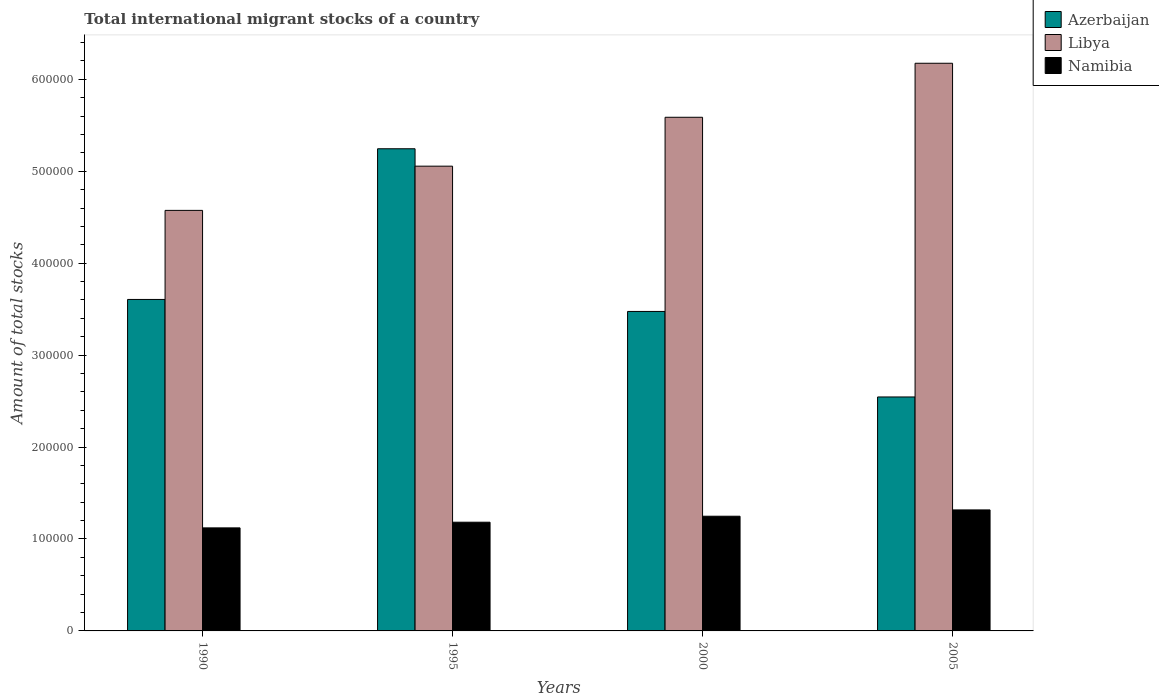How many different coloured bars are there?
Your answer should be compact. 3. Are the number of bars on each tick of the X-axis equal?
Ensure brevity in your answer.  Yes. How many bars are there on the 4th tick from the right?
Give a very brief answer. 3. In how many cases, is the number of bars for a given year not equal to the number of legend labels?
Ensure brevity in your answer.  0. What is the amount of total stocks in in Namibia in 2000?
Your answer should be compact. 1.25e+05. Across all years, what is the maximum amount of total stocks in in Namibia?
Offer a very short reply. 1.32e+05. Across all years, what is the minimum amount of total stocks in in Namibia?
Provide a short and direct response. 1.12e+05. What is the total amount of total stocks in in Namibia in the graph?
Make the answer very short. 4.87e+05. What is the difference between the amount of total stocks in in Azerbaijan in 1995 and that in 2005?
Your answer should be very brief. 2.70e+05. What is the difference between the amount of total stocks in in Azerbaijan in 2000 and the amount of total stocks in in Namibia in 1990?
Offer a very short reply. 2.35e+05. What is the average amount of total stocks in in Libya per year?
Give a very brief answer. 5.35e+05. In the year 1995, what is the difference between the amount of total stocks in in Azerbaijan and amount of total stocks in in Namibia?
Your answer should be compact. 4.06e+05. What is the ratio of the amount of total stocks in in Namibia in 1990 to that in 1995?
Provide a short and direct response. 0.95. Is the amount of total stocks in in Namibia in 2000 less than that in 2005?
Make the answer very short. Yes. Is the difference between the amount of total stocks in in Azerbaijan in 1990 and 1995 greater than the difference between the amount of total stocks in in Namibia in 1990 and 1995?
Give a very brief answer. No. What is the difference between the highest and the second highest amount of total stocks in in Namibia?
Your answer should be very brief. 6863. What is the difference between the highest and the lowest amount of total stocks in in Libya?
Give a very brief answer. 1.60e+05. In how many years, is the amount of total stocks in in Azerbaijan greater than the average amount of total stocks in in Azerbaijan taken over all years?
Ensure brevity in your answer.  1. Is the sum of the amount of total stocks in in Libya in 1990 and 1995 greater than the maximum amount of total stocks in in Namibia across all years?
Ensure brevity in your answer.  Yes. What does the 2nd bar from the left in 1995 represents?
Provide a short and direct response. Libya. What does the 1st bar from the right in 2000 represents?
Provide a succinct answer. Namibia. Is it the case that in every year, the sum of the amount of total stocks in in Libya and amount of total stocks in in Azerbaijan is greater than the amount of total stocks in in Namibia?
Keep it short and to the point. Yes. Are all the bars in the graph horizontal?
Provide a succinct answer. No. How many years are there in the graph?
Your answer should be very brief. 4. What is the difference between two consecutive major ticks on the Y-axis?
Your answer should be very brief. 1.00e+05. Are the values on the major ticks of Y-axis written in scientific E-notation?
Provide a succinct answer. No. Does the graph contain any zero values?
Provide a succinct answer. No. How many legend labels are there?
Your answer should be very brief. 3. What is the title of the graph?
Provide a succinct answer. Total international migrant stocks of a country. What is the label or title of the X-axis?
Provide a short and direct response. Years. What is the label or title of the Y-axis?
Give a very brief answer. Amount of total stocks. What is the Amount of total stocks in Azerbaijan in 1990?
Offer a terse response. 3.61e+05. What is the Amount of total stocks in Libya in 1990?
Keep it short and to the point. 4.57e+05. What is the Amount of total stocks of Namibia in 1990?
Provide a short and direct response. 1.12e+05. What is the Amount of total stocks in Azerbaijan in 1995?
Your response must be concise. 5.25e+05. What is the Amount of total stocks of Libya in 1995?
Give a very brief answer. 5.06e+05. What is the Amount of total stocks of Namibia in 1995?
Your response must be concise. 1.18e+05. What is the Amount of total stocks in Azerbaijan in 2000?
Your response must be concise. 3.48e+05. What is the Amount of total stocks of Libya in 2000?
Provide a short and direct response. 5.59e+05. What is the Amount of total stocks of Namibia in 2000?
Your response must be concise. 1.25e+05. What is the Amount of total stocks in Azerbaijan in 2005?
Your response must be concise. 2.55e+05. What is the Amount of total stocks in Libya in 2005?
Provide a succinct answer. 6.18e+05. What is the Amount of total stocks of Namibia in 2005?
Offer a very short reply. 1.32e+05. Across all years, what is the maximum Amount of total stocks in Azerbaijan?
Make the answer very short. 5.25e+05. Across all years, what is the maximum Amount of total stocks in Libya?
Provide a succinct answer. 6.18e+05. Across all years, what is the maximum Amount of total stocks in Namibia?
Your answer should be compact. 1.32e+05. Across all years, what is the minimum Amount of total stocks of Azerbaijan?
Your response must be concise. 2.55e+05. Across all years, what is the minimum Amount of total stocks of Libya?
Offer a very short reply. 4.57e+05. Across all years, what is the minimum Amount of total stocks of Namibia?
Give a very brief answer. 1.12e+05. What is the total Amount of total stocks in Azerbaijan in the graph?
Your answer should be very brief. 1.49e+06. What is the total Amount of total stocks in Libya in the graph?
Keep it short and to the point. 2.14e+06. What is the total Amount of total stocks in Namibia in the graph?
Offer a very short reply. 4.87e+05. What is the difference between the Amount of total stocks in Azerbaijan in 1990 and that in 1995?
Ensure brevity in your answer.  -1.64e+05. What is the difference between the Amount of total stocks in Libya in 1990 and that in 1995?
Offer a terse response. -4.81e+04. What is the difference between the Amount of total stocks in Namibia in 1990 and that in 1995?
Offer a terse response. -6166. What is the difference between the Amount of total stocks of Azerbaijan in 1990 and that in 2000?
Offer a very short reply. 1.31e+04. What is the difference between the Amount of total stocks in Libya in 1990 and that in 2000?
Give a very brief answer. -1.01e+05. What is the difference between the Amount of total stocks in Namibia in 1990 and that in 2000?
Provide a short and direct response. -1.27e+04. What is the difference between the Amount of total stocks in Azerbaijan in 1990 and that in 2005?
Offer a very short reply. 1.06e+05. What is the difference between the Amount of total stocks of Libya in 1990 and that in 2005?
Offer a terse response. -1.60e+05. What is the difference between the Amount of total stocks in Namibia in 1990 and that in 2005?
Provide a succinct answer. -1.95e+04. What is the difference between the Amount of total stocks in Azerbaijan in 1995 and that in 2000?
Offer a very short reply. 1.77e+05. What is the difference between the Amount of total stocks in Libya in 1995 and that in 2000?
Give a very brief answer. -5.32e+04. What is the difference between the Amount of total stocks of Namibia in 1995 and that in 2000?
Your answer should be very brief. -6505. What is the difference between the Amount of total stocks of Azerbaijan in 1995 and that in 2005?
Keep it short and to the point. 2.70e+05. What is the difference between the Amount of total stocks of Libya in 1995 and that in 2005?
Offer a terse response. -1.12e+05. What is the difference between the Amount of total stocks in Namibia in 1995 and that in 2005?
Offer a very short reply. -1.34e+04. What is the difference between the Amount of total stocks in Azerbaijan in 2000 and that in 2005?
Your answer should be very brief. 9.30e+04. What is the difference between the Amount of total stocks in Libya in 2000 and that in 2005?
Provide a succinct answer. -5.88e+04. What is the difference between the Amount of total stocks in Namibia in 2000 and that in 2005?
Keep it short and to the point. -6863. What is the difference between the Amount of total stocks in Azerbaijan in 1990 and the Amount of total stocks in Libya in 1995?
Offer a very short reply. -1.45e+05. What is the difference between the Amount of total stocks of Azerbaijan in 1990 and the Amount of total stocks of Namibia in 1995?
Offer a very short reply. 2.42e+05. What is the difference between the Amount of total stocks in Libya in 1990 and the Amount of total stocks in Namibia in 1995?
Provide a succinct answer. 3.39e+05. What is the difference between the Amount of total stocks of Azerbaijan in 1990 and the Amount of total stocks of Libya in 2000?
Offer a terse response. -1.98e+05. What is the difference between the Amount of total stocks in Azerbaijan in 1990 and the Amount of total stocks in Namibia in 2000?
Ensure brevity in your answer.  2.36e+05. What is the difference between the Amount of total stocks in Libya in 1990 and the Amount of total stocks in Namibia in 2000?
Offer a very short reply. 3.33e+05. What is the difference between the Amount of total stocks of Azerbaijan in 1990 and the Amount of total stocks of Libya in 2005?
Make the answer very short. -2.57e+05. What is the difference between the Amount of total stocks of Azerbaijan in 1990 and the Amount of total stocks of Namibia in 2005?
Your answer should be very brief. 2.29e+05. What is the difference between the Amount of total stocks of Libya in 1990 and the Amount of total stocks of Namibia in 2005?
Your response must be concise. 3.26e+05. What is the difference between the Amount of total stocks in Azerbaijan in 1995 and the Amount of total stocks in Libya in 2000?
Your answer should be very brief. -3.43e+04. What is the difference between the Amount of total stocks in Azerbaijan in 1995 and the Amount of total stocks in Namibia in 2000?
Provide a short and direct response. 4.00e+05. What is the difference between the Amount of total stocks in Libya in 1995 and the Amount of total stocks in Namibia in 2000?
Give a very brief answer. 3.81e+05. What is the difference between the Amount of total stocks of Azerbaijan in 1995 and the Amount of total stocks of Libya in 2005?
Your response must be concise. -9.30e+04. What is the difference between the Amount of total stocks of Azerbaijan in 1995 and the Amount of total stocks of Namibia in 2005?
Offer a terse response. 3.93e+05. What is the difference between the Amount of total stocks of Libya in 1995 and the Amount of total stocks of Namibia in 2005?
Keep it short and to the point. 3.74e+05. What is the difference between the Amount of total stocks in Azerbaijan in 2000 and the Amount of total stocks in Libya in 2005?
Offer a terse response. -2.70e+05. What is the difference between the Amount of total stocks in Azerbaijan in 2000 and the Amount of total stocks in Namibia in 2005?
Provide a succinct answer. 2.16e+05. What is the difference between the Amount of total stocks of Libya in 2000 and the Amount of total stocks of Namibia in 2005?
Provide a succinct answer. 4.27e+05. What is the average Amount of total stocks of Azerbaijan per year?
Your response must be concise. 3.72e+05. What is the average Amount of total stocks of Libya per year?
Offer a terse response. 5.35e+05. What is the average Amount of total stocks of Namibia per year?
Your response must be concise. 1.22e+05. In the year 1990, what is the difference between the Amount of total stocks in Azerbaijan and Amount of total stocks in Libya?
Make the answer very short. -9.69e+04. In the year 1990, what is the difference between the Amount of total stocks of Azerbaijan and Amount of total stocks of Namibia?
Ensure brevity in your answer.  2.49e+05. In the year 1990, what is the difference between the Amount of total stocks of Libya and Amount of total stocks of Namibia?
Give a very brief answer. 3.45e+05. In the year 1995, what is the difference between the Amount of total stocks of Azerbaijan and Amount of total stocks of Libya?
Your answer should be very brief. 1.89e+04. In the year 1995, what is the difference between the Amount of total stocks in Azerbaijan and Amount of total stocks in Namibia?
Offer a terse response. 4.06e+05. In the year 1995, what is the difference between the Amount of total stocks of Libya and Amount of total stocks of Namibia?
Keep it short and to the point. 3.87e+05. In the year 2000, what is the difference between the Amount of total stocks in Azerbaijan and Amount of total stocks in Libya?
Offer a terse response. -2.11e+05. In the year 2000, what is the difference between the Amount of total stocks of Azerbaijan and Amount of total stocks of Namibia?
Offer a terse response. 2.23e+05. In the year 2000, what is the difference between the Amount of total stocks in Libya and Amount of total stocks in Namibia?
Offer a very short reply. 4.34e+05. In the year 2005, what is the difference between the Amount of total stocks in Azerbaijan and Amount of total stocks in Libya?
Make the answer very short. -3.63e+05. In the year 2005, what is the difference between the Amount of total stocks in Azerbaijan and Amount of total stocks in Namibia?
Offer a terse response. 1.23e+05. In the year 2005, what is the difference between the Amount of total stocks in Libya and Amount of total stocks in Namibia?
Make the answer very short. 4.86e+05. What is the ratio of the Amount of total stocks of Azerbaijan in 1990 to that in 1995?
Offer a terse response. 0.69. What is the ratio of the Amount of total stocks of Libya in 1990 to that in 1995?
Your answer should be compact. 0.9. What is the ratio of the Amount of total stocks in Namibia in 1990 to that in 1995?
Make the answer very short. 0.95. What is the ratio of the Amount of total stocks of Azerbaijan in 1990 to that in 2000?
Offer a terse response. 1.04. What is the ratio of the Amount of total stocks of Libya in 1990 to that in 2000?
Ensure brevity in your answer.  0.82. What is the ratio of the Amount of total stocks in Namibia in 1990 to that in 2000?
Ensure brevity in your answer.  0.9. What is the ratio of the Amount of total stocks in Azerbaijan in 1990 to that in 2005?
Keep it short and to the point. 1.42. What is the ratio of the Amount of total stocks of Libya in 1990 to that in 2005?
Provide a succinct answer. 0.74. What is the ratio of the Amount of total stocks in Namibia in 1990 to that in 2005?
Make the answer very short. 0.85. What is the ratio of the Amount of total stocks of Azerbaijan in 1995 to that in 2000?
Your answer should be very brief. 1.51. What is the ratio of the Amount of total stocks of Libya in 1995 to that in 2000?
Make the answer very short. 0.9. What is the ratio of the Amount of total stocks in Namibia in 1995 to that in 2000?
Your answer should be compact. 0.95. What is the ratio of the Amount of total stocks of Azerbaijan in 1995 to that in 2005?
Offer a very short reply. 2.06. What is the ratio of the Amount of total stocks of Libya in 1995 to that in 2005?
Your answer should be very brief. 0.82. What is the ratio of the Amount of total stocks of Namibia in 1995 to that in 2005?
Make the answer very short. 0.9. What is the ratio of the Amount of total stocks in Azerbaijan in 2000 to that in 2005?
Your answer should be very brief. 1.37. What is the ratio of the Amount of total stocks in Libya in 2000 to that in 2005?
Your answer should be compact. 0.9. What is the ratio of the Amount of total stocks in Namibia in 2000 to that in 2005?
Give a very brief answer. 0.95. What is the difference between the highest and the second highest Amount of total stocks in Azerbaijan?
Your response must be concise. 1.64e+05. What is the difference between the highest and the second highest Amount of total stocks of Libya?
Your response must be concise. 5.88e+04. What is the difference between the highest and the second highest Amount of total stocks of Namibia?
Keep it short and to the point. 6863. What is the difference between the highest and the lowest Amount of total stocks of Azerbaijan?
Your answer should be very brief. 2.70e+05. What is the difference between the highest and the lowest Amount of total stocks of Libya?
Provide a succinct answer. 1.60e+05. What is the difference between the highest and the lowest Amount of total stocks in Namibia?
Your answer should be very brief. 1.95e+04. 